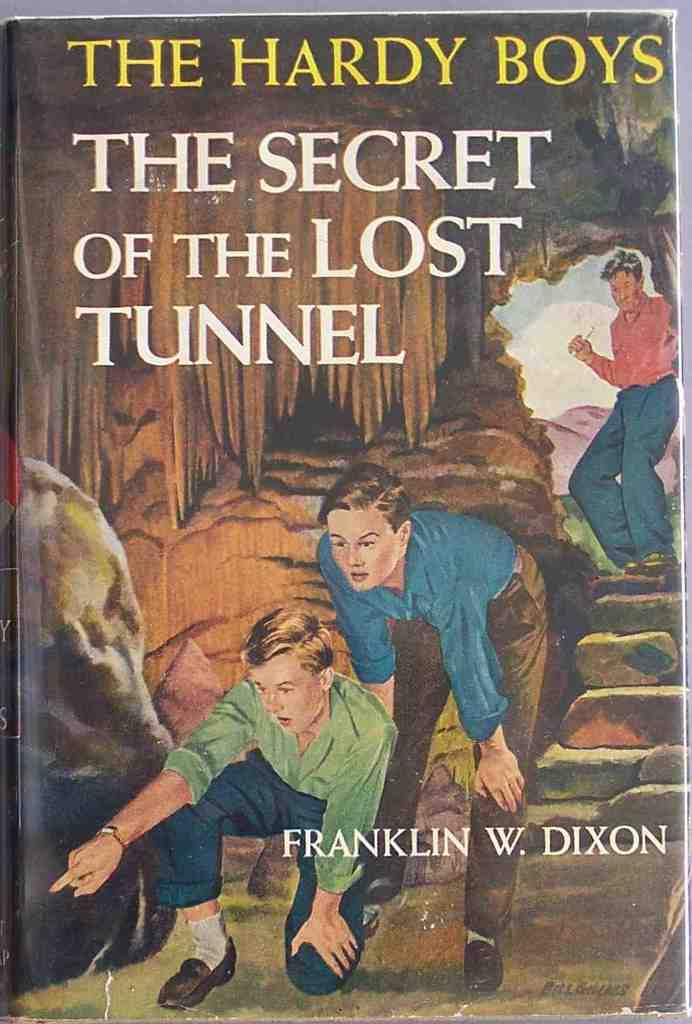Provide a one-sentence caption for the provided image. A book series named The Hardy Boys by Franklin W. Dixon. 